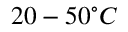Convert formula to latex. <formula><loc_0><loc_0><loc_500><loc_500>2 0 - 5 0 ^ { \circ } C</formula> 